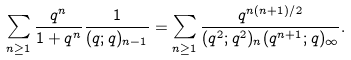Convert formula to latex. <formula><loc_0><loc_0><loc_500><loc_500>\sum _ { n \geq 1 } \frac { q ^ { n } } { 1 + q ^ { n } } \frac { 1 } { ( q ; q ) _ { n - 1 } } = \sum _ { n \geq 1 } \frac { q ^ { n ( n + 1 ) / 2 } } { ( q ^ { 2 } ; q ^ { 2 } ) _ { n } ( q ^ { n + 1 } ; q ) _ { \infty } } .</formula> 